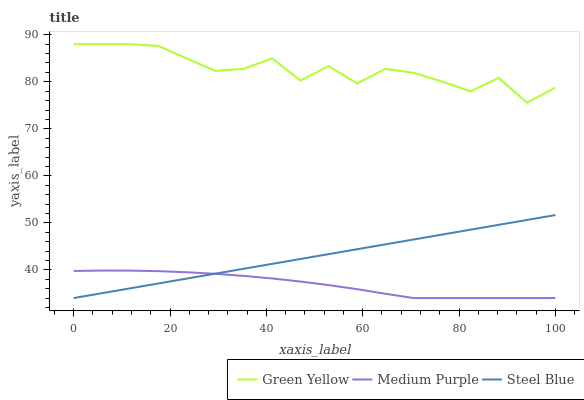Does Medium Purple have the minimum area under the curve?
Answer yes or no. Yes. Does Green Yellow have the maximum area under the curve?
Answer yes or no. Yes. Does Steel Blue have the minimum area under the curve?
Answer yes or no. No. Does Steel Blue have the maximum area under the curve?
Answer yes or no. No. Is Steel Blue the smoothest?
Answer yes or no. Yes. Is Green Yellow the roughest?
Answer yes or no. Yes. Is Green Yellow the smoothest?
Answer yes or no. No. Is Steel Blue the roughest?
Answer yes or no. No. Does Medium Purple have the lowest value?
Answer yes or no. Yes. Does Green Yellow have the lowest value?
Answer yes or no. No. Does Green Yellow have the highest value?
Answer yes or no. Yes. Does Steel Blue have the highest value?
Answer yes or no. No. Is Medium Purple less than Green Yellow?
Answer yes or no. Yes. Is Green Yellow greater than Medium Purple?
Answer yes or no. Yes. Does Medium Purple intersect Steel Blue?
Answer yes or no. Yes. Is Medium Purple less than Steel Blue?
Answer yes or no. No. Is Medium Purple greater than Steel Blue?
Answer yes or no. No. Does Medium Purple intersect Green Yellow?
Answer yes or no. No. 